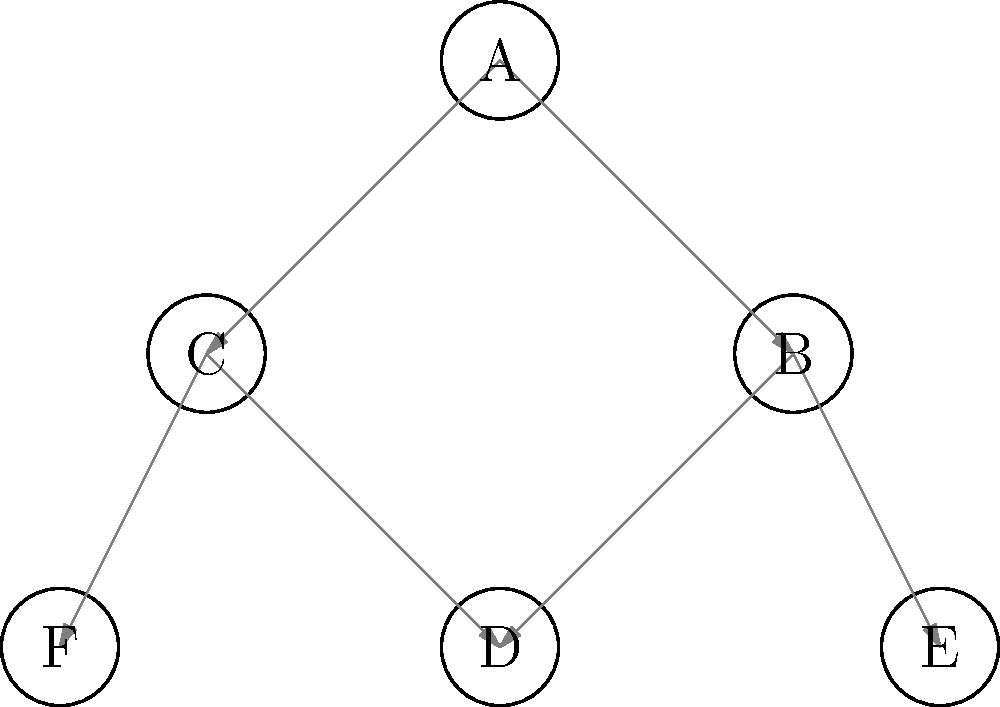In the directed graph representing a legal precedent hierarchy, where each node represents a court decision and each directed edge represents a citation, what is the minimum number of decisions that need to be overturned to make decision D no longer reachable from decision A? To solve this problem, we need to analyze the paths from A to D and determine the minimum number of decisions that, if overturned, would break all paths from A to D. Let's approach this step-by-step:

1. Identify all paths from A to D:
   Path 1: A → B → D
   Path 2: A → C → D

2. Observe that there are two distinct paths from A to D, and they do not share any intermediate nodes.

3. To make D unreachable from A, we need to break both paths.

4. We have two options to break these paths:
   Option 1: Overturn B and C
   Option 2: Overturn D

5. Option 2 (overturning D) requires overturning only one decision, while Option 1 requires overturning two decisions.

6. Therefore, the minimum number of decisions that need to be overturned is 1, which is achieved by overturning decision D.

By overturning D, we effectively remove it from the precedent hierarchy, making it unreachable from A through any path.
Answer: 1 